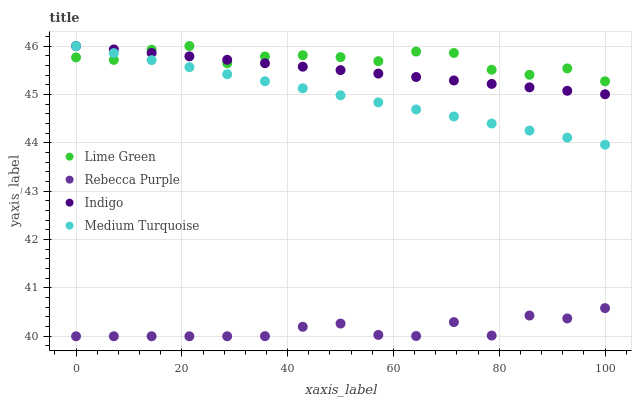Does Rebecca Purple have the minimum area under the curve?
Answer yes or no. Yes. Does Lime Green have the maximum area under the curve?
Answer yes or no. Yes. Does Lime Green have the minimum area under the curve?
Answer yes or no. No. Does Rebecca Purple have the maximum area under the curve?
Answer yes or no. No. Is Medium Turquoise the smoothest?
Answer yes or no. Yes. Is Lime Green the roughest?
Answer yes or no. Yes. Is Rebecca Purple the smoothest?
Answer yes or no. No. Is Rebecca Purple the roughest?
Answer yes or no. No. Does Rebecca Purple have the lowest value?
Answer yes or no. Yes. Does Lime Green have the lowest value?
Answer yes or no. No. Does Medium Turquoise have the highest value?
Answer yes or no. Yes. Does Rebecca Purple have the highest value?
Answer yes or no. No. Is Rebecca Purple less than Medium Turquoise?
Answer yes or no. Yes. Is Indigo greater than Rebecca Purple?
Answer yes or no. Yes. Does Lime Green intersect Indigo?
Answer yes or no. Yes. Is Lime Green less than Indigo?
Answer yes or no. No. Is Lime Green greater than Indigo?
Answer yes or no. No. Does Rebecca Purple intersect Medium Turquoise?
Answer yes or no. No. 